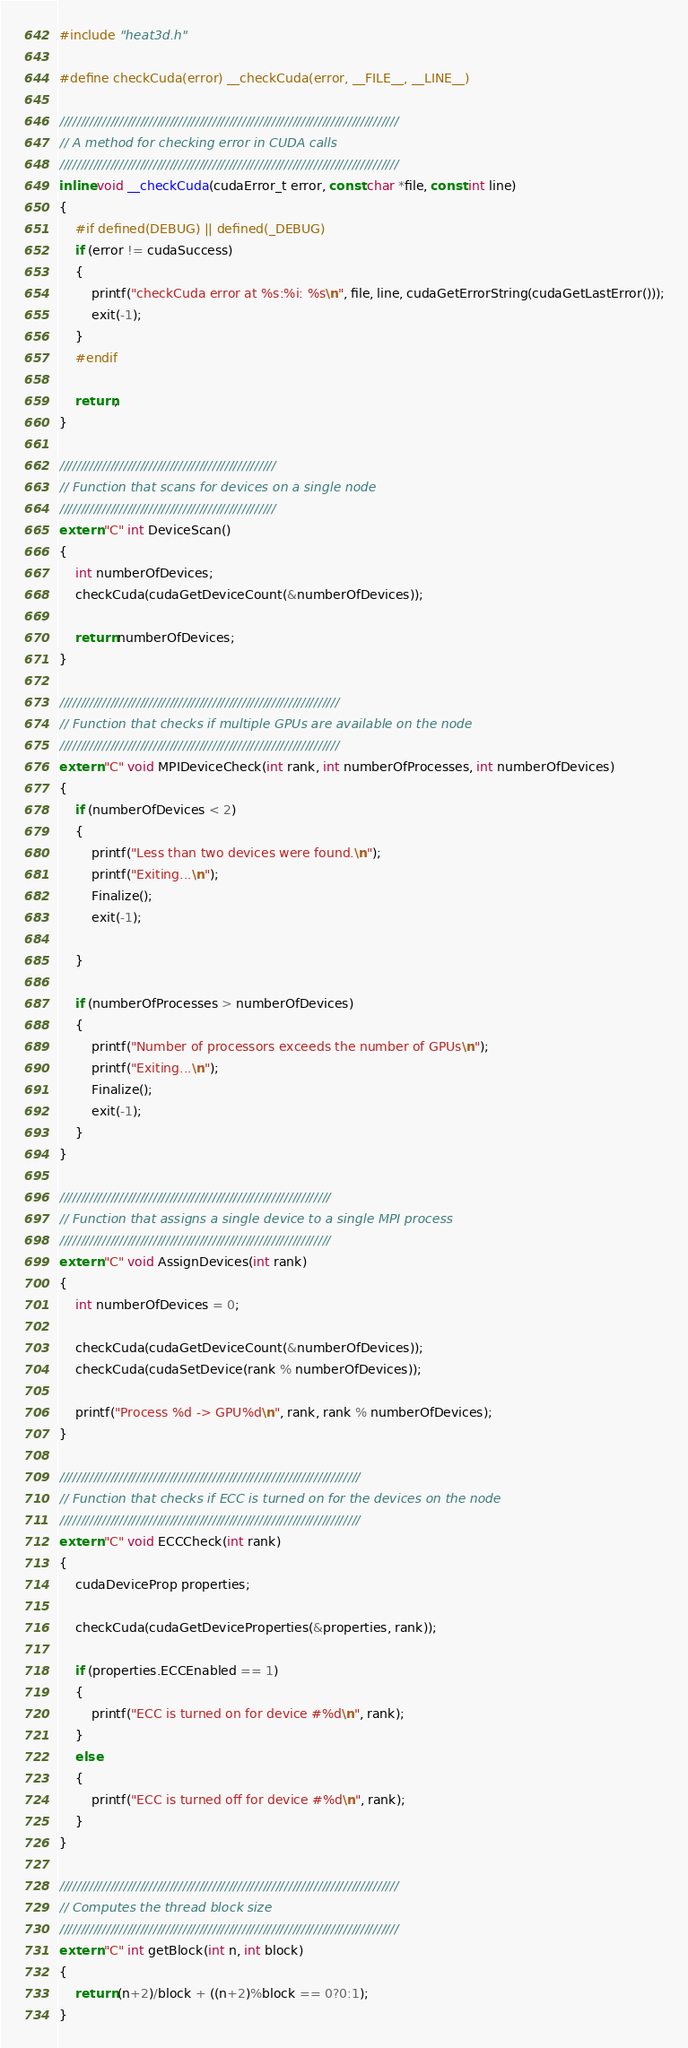<code> <loc_0><loc_0><loc_500><loc_500><_Cuda_>#include "heat3d.h"

#define checkCuda(error) __checkCuda(error, __FILE__, __LINE__)

////////////////////////////////////////////////////////////////////////////////
// A method for checking error in CUDA calls
////////////////////////////////////////////////////////////////////////////////
inline void __checkCuda(cudaError_t error, const char *file, const int line)
{
	#if defined(DEBUG) || defined(_DEBUG)
	if (error != cudaSuccess)
	{
		printf("checkCuda error at %s:%i: %s\n", file, line, cudaGetErrorString(cudaGetLastError()));
		exit(-1);
	}
	#endif

	return;
}

///////////////////////////////////////////////////
// Function that scans for devices on a single node
///////////////////////////////////////////////////
extern "C" int DeviceScan()
{
	int numberOfDevices;
	checkCuda(cudaGetDeviceCount(&numberOfDevices));

	return numberOfDevices;
}

//////////////////////////////////////////////////////////////////
// Function that checks if multiple GPUs are available on the node
//////////////////////////////////////////////////////////////////
extern "C" void MPIDeviceCheck(int rank, int numberOfProcesses, int numberOfDevices)
{
	if (numberOfDevices < 2)
	{
		printf("Less than two devices were found.\n");
		printf("Exiting...\n");
		Finalize();
		exit(-1);

	}

	if (numberOfProcesses > numberOfDevices)
	{
		printf("Number of processors exceeds the number of GPUs\n");
		printf("Exiting...\n");
		Finalize();
		exit(-1);
	}
}

////////////////////////////////////////////////////////////////
// Function that assigns a single device to a single MPI process
////////////////////////////////////////////////////////////////
extern "C" void AssignDevices(int rank)
{
	int numberOfDevices = 0;

	checkCuda(cudaGetDeviceCount(&numberOfDevices));
	checkCuda(cudaSetDevice(rank % numberOfDevices));

	printf("Process %d -> GPU%d\n", rank, rank % numberOfDevices);
}

///////////////////////////////////////////////////////////////////////
// Function that checks if ECC is turned on for the devices on the node
///////////////////////////////////////////////////////////////////////
extern "C" void ECCCheck(int rank)
{
	cudaDeviceProp properties;

    checkCuda(cudaGetDeviceProperties(&properties, rank));

    if (properties.ECCEnabled == 1)
    {
        printf("ECC is turned on for device #%d\n", rank);
    }
    else
    {
        printf("ECC is turned off for device #%d\n", rank);
    }
}

////////////////////////////////////////////////////////////////////////////////
// Computes the thread block size
////////////////////////////////////////////////////////////////////////////////
extern "C" int getBlock(int n, int block)
{
	return (n+2)/block + ((n+2)%block == 0?0:1);
}
</code> 